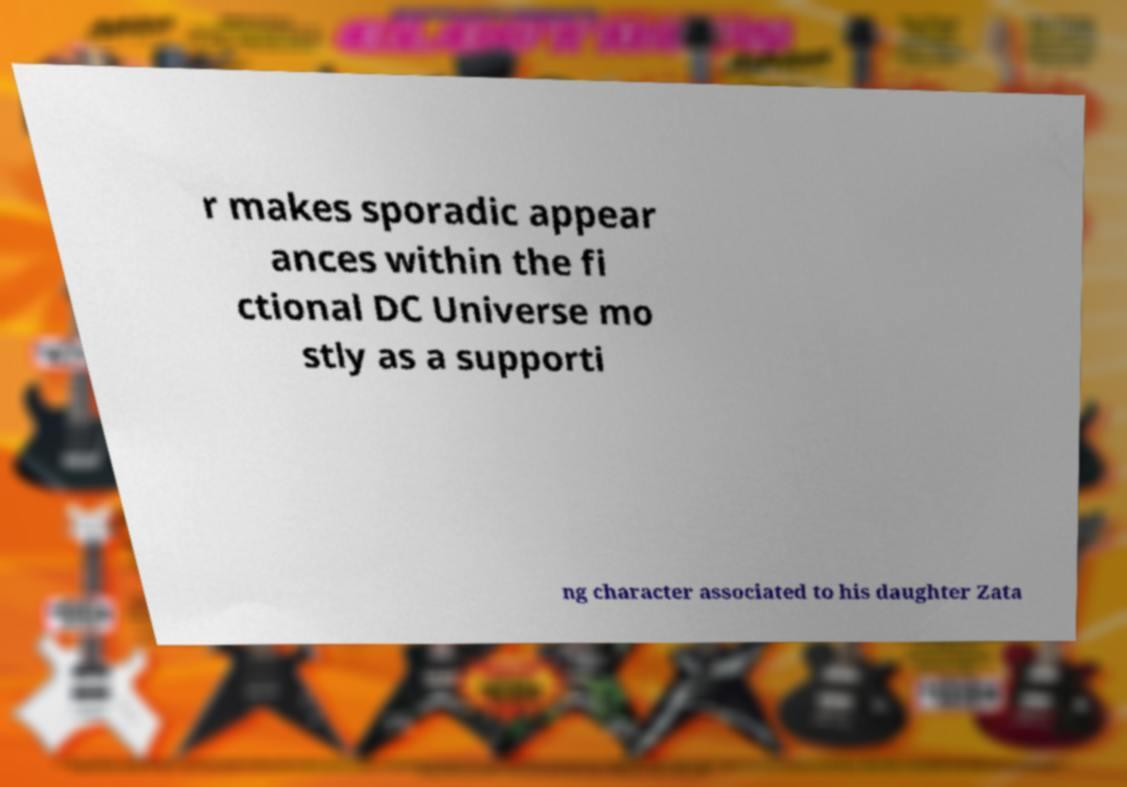What messages or text are displayed in this image? I need them in a readable, typed format. r makes sporadic appear ances within the fi ctional DC Universe mo stly as a supporti ng character associated to his daughter Zata 